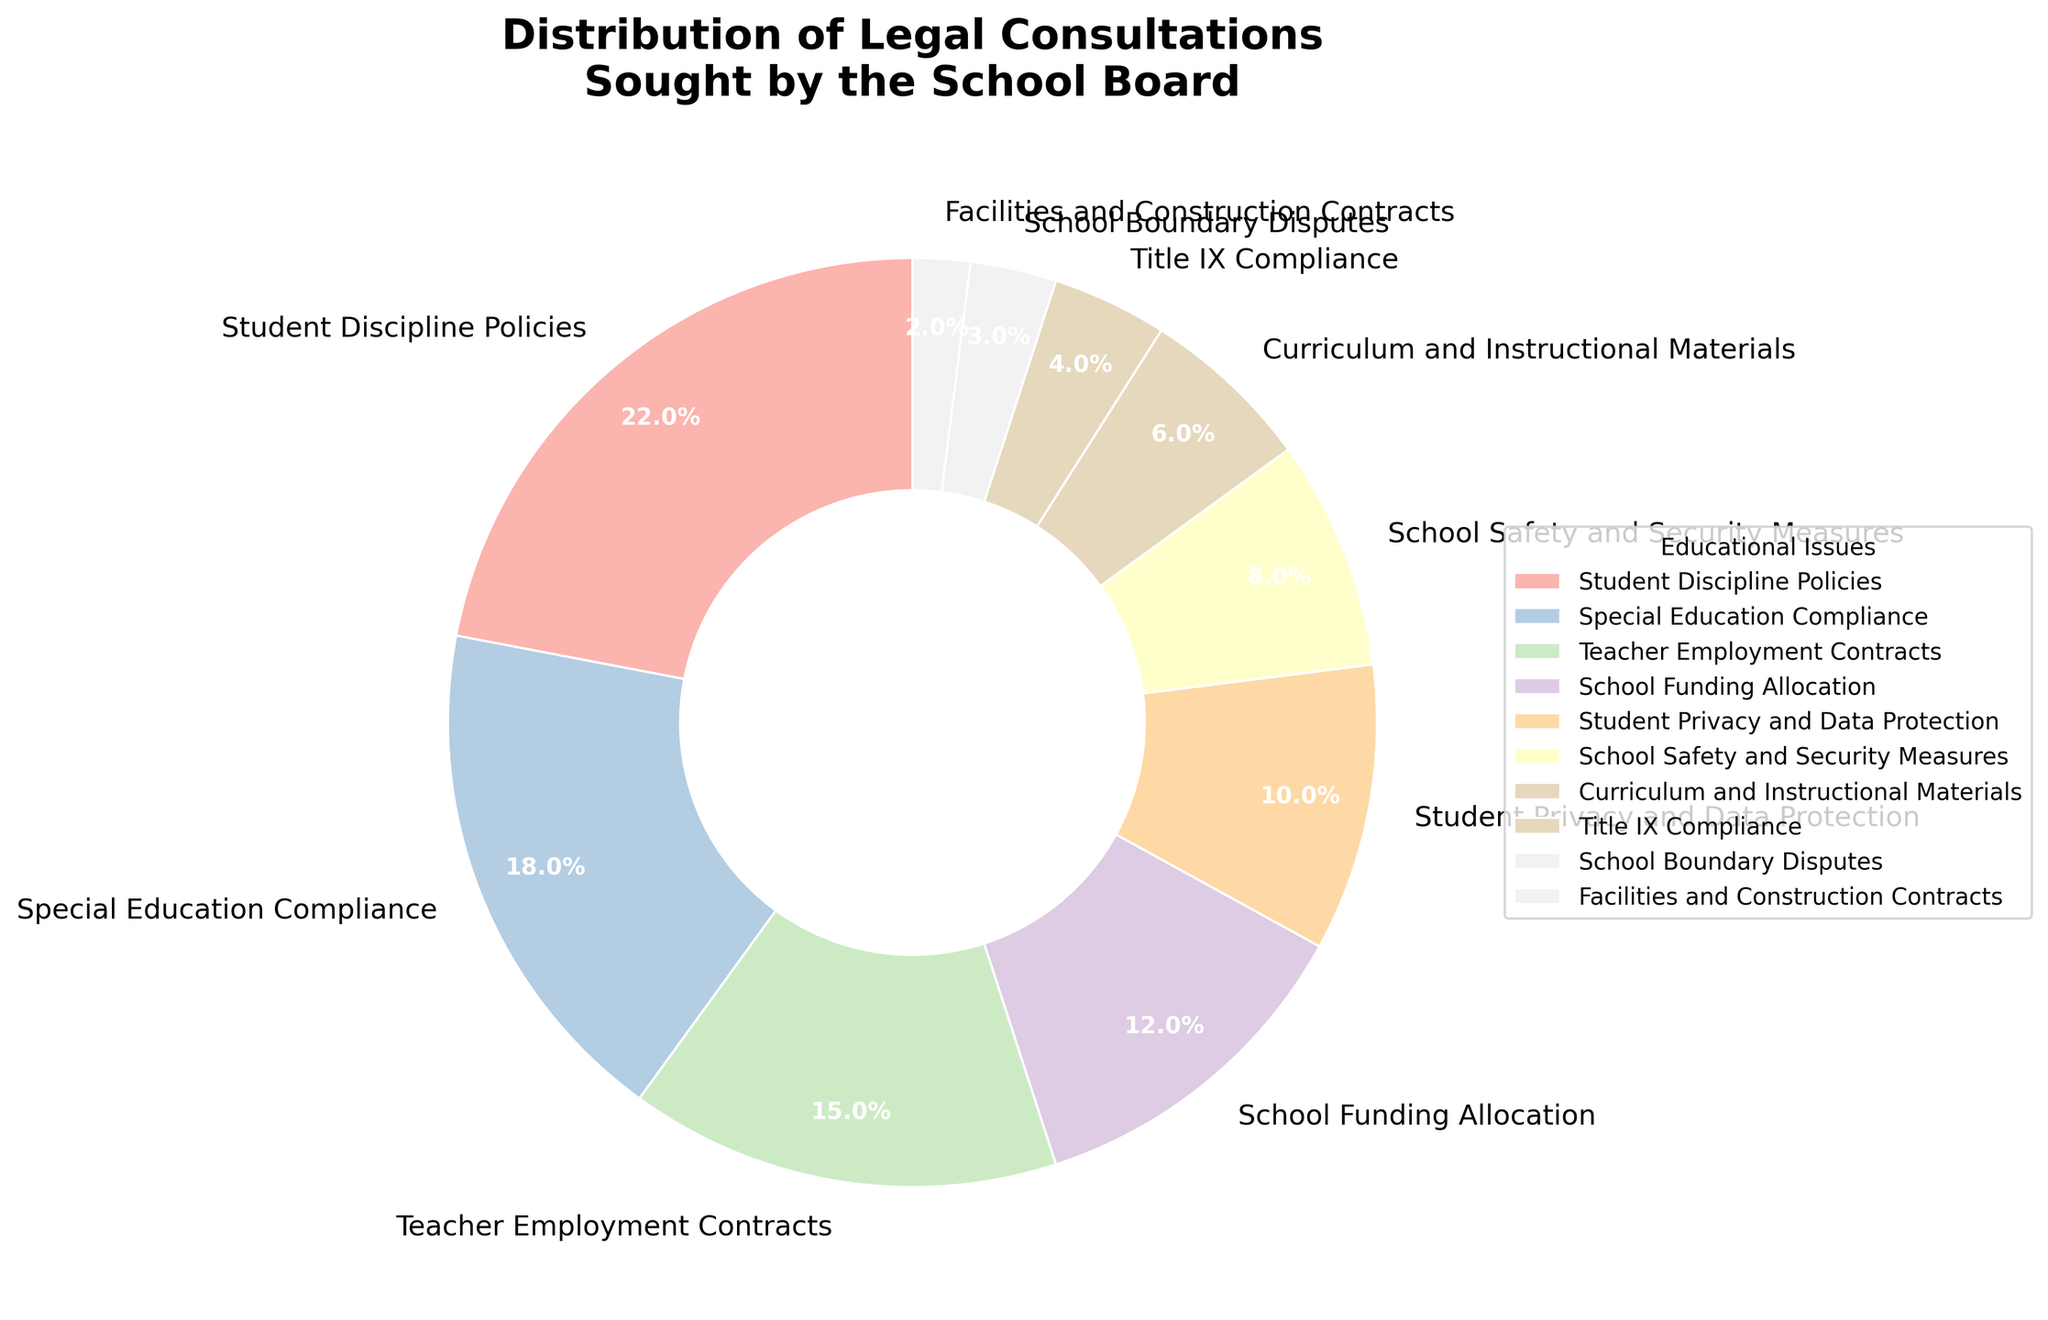Which category has the largest percentage of legal consultations? By examining the pie chart, we can identify the category with the largest slice, which represents the highest percentage.
Answer: Student Discipline Policies What is the combined percentage of legal consultations for Teacher Employment Contracts and School Funding Allocation? The pie chart shows Teacher Employment Contracts at 15% and School Funding Allocation at 12%. Adding these percentages gives 15% + 12%.
Answer: 27% Which category has a smaller percentage, School Safety and Security Measures or Student Privacy and Data Protection? By comparing the sizes of the slices for these categories, we see that School Safety and Security Measures is 8% and Student Privacy and Data Protection is 10%. Since 8% is smaller than 10%, School Safety and Security Measures has a smaller percentage.
Answer: School Safety and Security Measures What is the difference in the percentage of legal consultations between Special Education Compliance and Title IX Compliance? The pie chart indicates Special Education Compliance at 18% and Title IX Compliance at 4%. The difference is calculated as 18% - 4%.
Answer: 14% How many categories have a percentage of legal consultations less than 10%? Reviewing the pie chart, we note the percentages less than 10%: School Safety and Security Measures (8%), Curriculum and Instructional Materials (6%), Title IX Compliance (4%), School Boundary Disputes (3%), and Facilities and Construction Contracts (2%). Counting these, we get 5 categories.
Answer: 5 If the sum of all percentages must equal 100%, verify if the given percentages add up to this total? Adding each percentage from the chart: 22% + 18% + 15% + 12% + 10% + 8% + 6% + 4% + 3% + 2%. The sum should be checked: 22 + 18 + 15 + 12 + 10 + 8 + 6 + 4 + 3 + 2 = 100.
Answer: 100 What percentage of legal consultations involve issues related to school facilities (School Boundary Disputes and Facilities and Construction Contracts combined)? The pie chart shows School Boundary Disputes at 3% and Facilities and Construction Contracts at 2%. Adding these percentages: 3% + 2%.
Answer: 5% Which issue has the closest percentage to the average percentage of all categories? First, calculate the average percentage: (22 + 18 + 15 + 12 + 10 + 8 + 6 + 4 + 3 + 2) / 10 = 10%. Then, identify the issue closest to 10%. The closest percentage is Student Privacy and Data Protection, which is exactly 10%.
Answer: Student Privacy and Data Protection 